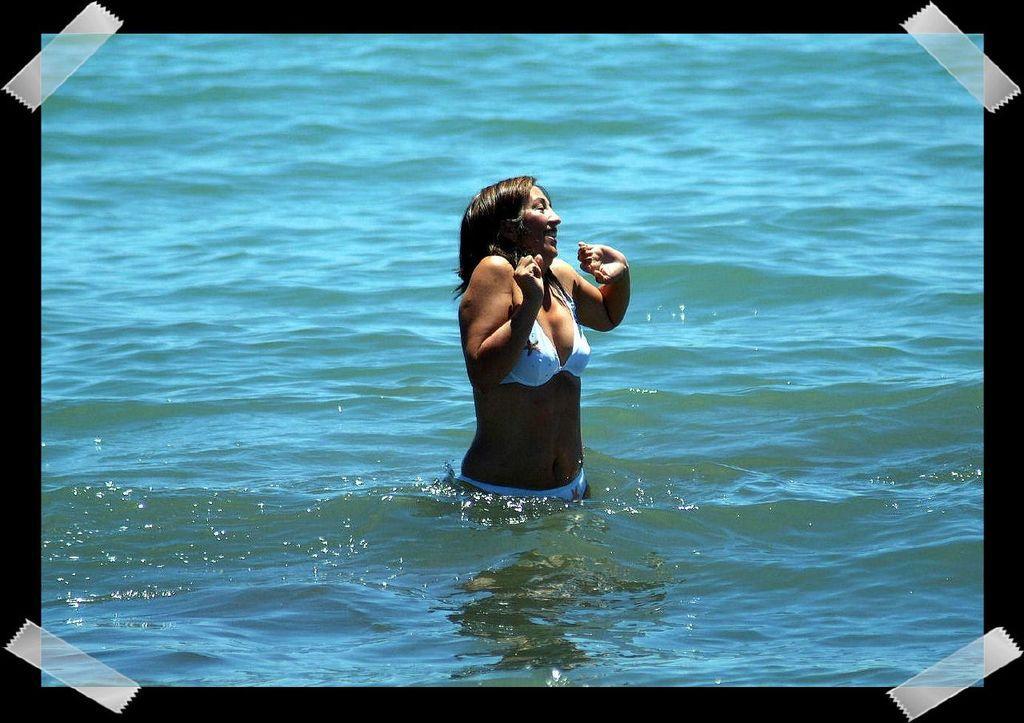In one or two sentences, can you explain what this image depicts? In this picture I can see a photo, where I can see a woman in the water and I see that, the woman is wearing white color swimming suit. 